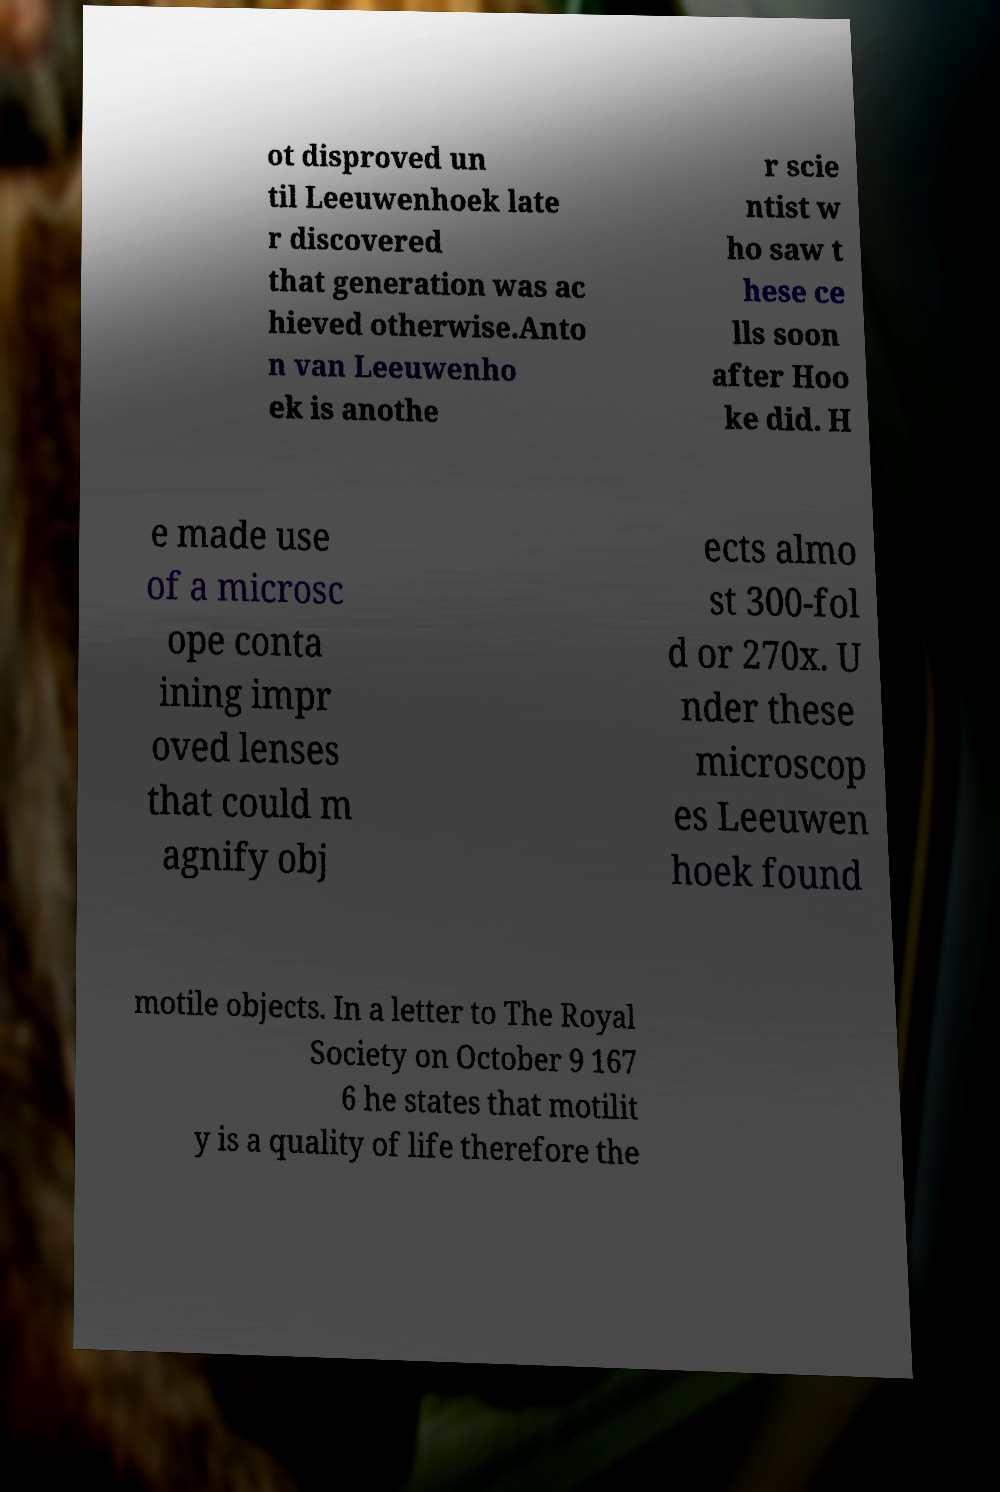Could you assist in decoding the text presented in this image and type it out clearly? ot disproved un til Leeuwenhoek late r discovered that generation was ac hieved otherwise.Anto n van Leeuwenho ek is anothe r scie ntist w ho saw t hese ce lls soon after Hoo ke did. H e made use of a microsc ope conta ining impr oved lenses that could m agnify obj ects almo st 300-fol d or 270x. U nder these microscop es Leeuwen hoek found motile objects. In a letter to The Royal Society on October 9 167 6 he states that motilit y is a quality of life therefore the 